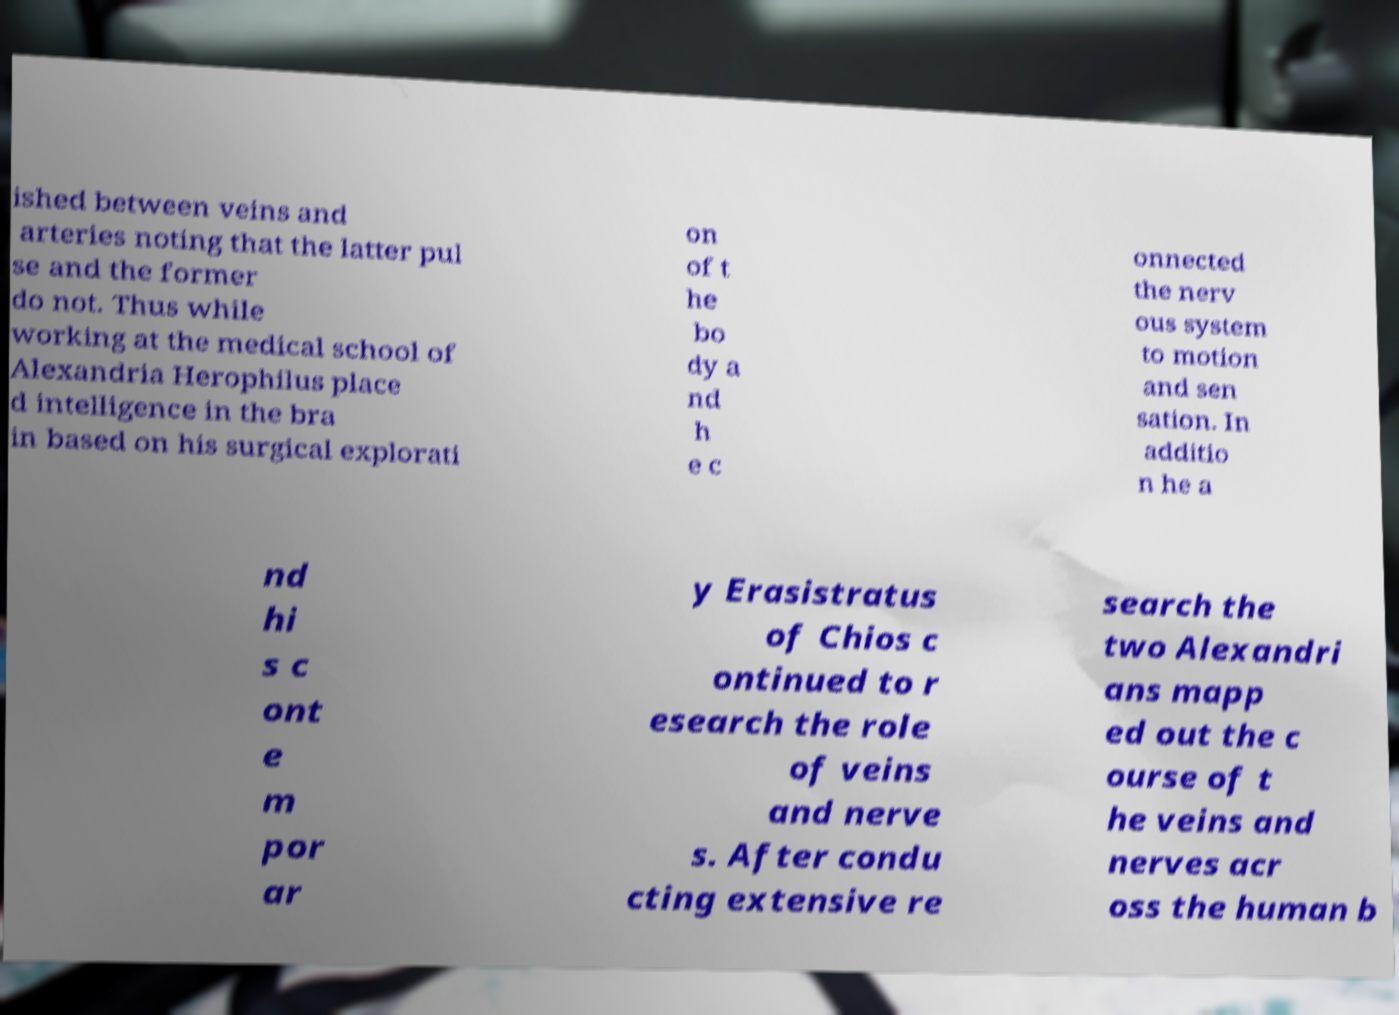There's text embedded in this image that I need extracted. Can you transcribe it verbatim? ished between veins and arteries noting that the latter pul se and the former do not. Thus while working at the medical school of Alexandria Herophilus place d intelligence in the bra in based on his surgical explorati on of t he bo dy a nd h e c onnected the nerv ous system to motion and sen sation. In additio n he a nd hi s c ont e m por ar y Erasistratus of Chios c ontinued to r esearch the role of veins and nerve s. After condu cting extensive re search the two Alexandri ans mapp ed out the c ourse of t he veins and nerves acr oss the human b 